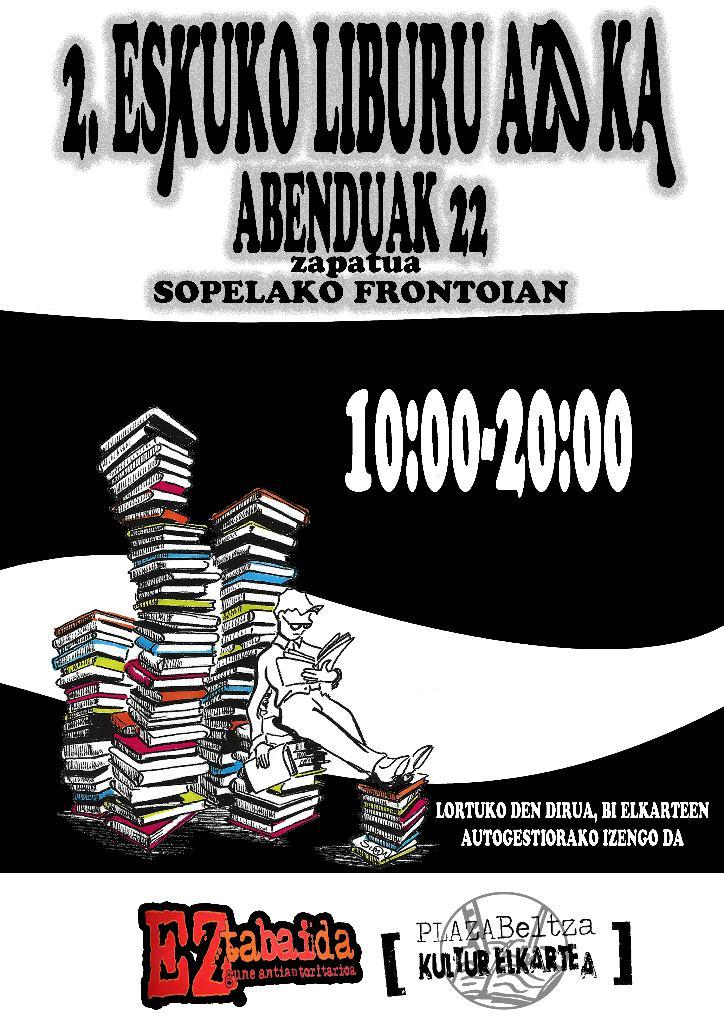<image>
Relay a brief, clear account of the picture shown. An ad for EZ tabaida from 10:00 to 20:00. 